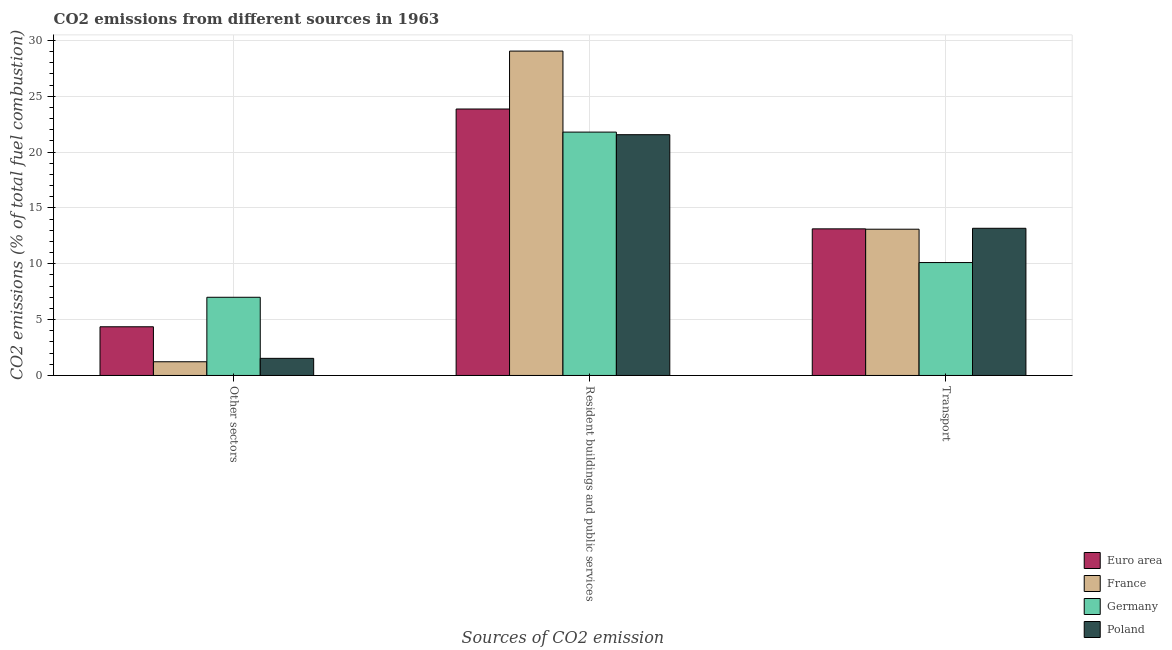How many different coloured bars are there?
Provide a short and direct response. 4. How many groups of bars are there?
Offer a terse response. 3. How many bars are there on the 1st tick from the left?
Give a very brief answer. 4. How many bars are there on the 3rd tick from the right?
Your answer should be very brief. 4. What is the label of the 3rd group of bars from the left?
Offer a very short reply. Transport. What is the percentage of co2 emissions from other sectors in Euro area?
Offer a terse response. 4.36. Across all countries, what is the maximum percentage of co2 emissions from transport?
Your response must be concise. 13.17. Across all countries, what is the minimum percentage of co2 emissions from other sectors?
Give a very brief answer. 1.23. In which country was the percentage of co2 emissions from resident buildings and public services minimum?
Provide a succinct answer. Poland. What is the total percentage of co2 emissions from other sectors in the graph?
Keep it short and to the point. 14.11. What is the difference between the percentage of co2 emissions from transport in Euro area and that in France?
Provide a succinct answer. 0.03. What is the difference between the percentage of co2 emissions from other sectors in Euro area and the percentage of co2 emissions from resident buildings and public services in France?
Keep it short and to the point. -24.68. What is the average percentage of co2 emissions from transport per country?
Provide a short and direct response. 12.37. What is the difference between the percentage of co2 emissions from resident buildings and public services and percentage of co2 emissions from transport in Euro area?
Offer a very short reply. 10.73. In how many countries, is the percentage of co2 emissions from other sectors greater than 1 %?
Your response must be concise. 4. What is the ratio of the percentage of co2 emissions from resident buildings and public services in Germany to that in Poland?
Provide a succinct answer. 1.01. Is the percentage of co2 emissions from transport in France less than that in Poland?
Your answer should be very brief. Yes. What is the difference between the highest and the second highest percentage of co2 emissions from transport?
Your answer should be very brief. 0.05. What is the difference between the highest and the lowest percentage of co2 emissions from resident buildings and public services?
Make the answer very short. 7.48. In how many countries, is the percentage of co2 emissions from other sectors greater than the average percentage of co2 emissions from other sectors taken over all countries?
Give a very brief answer. 2. What does the 3rd bar from the right in Other sectors represents?
Your answer should be very brief. France. Is it the case that in every country, the sum of the percentage of co2 emissions from other sectors and percentage of co2 emissions from resident buildings and public services is greater than the percentage of co2 emissions from transport?
Make the answer very short. Yes. How many bars are there?
Offer a very short reply. 12. Are all the bars in the graph horizontal?
Your answer should be very brief. No. How many countries are there in the graph?
Provide a succinct answer. 4. What is the title of the graph?
Your answer should be compact. CO2 emissions from different sources in 1963. What is the label or title of the X-axis?
Ensure brevity in your answer.  Sources of CO2 emission. What is the label or title of the Y-axis?
Give a very brief answer. CO2 emissions (% of total fuel combustion). What is the CO2 emissions (% of total fuel combustion) in Euro area in Other sectors?
Keep it short and to the point. 4.36. What is the CO2 emissions (% of total fuel combustion) of France in Other sectors?
Provide a succinct answer. 1.23. What is the CO2 emissions (% of total fuel combustion) of Germany in Other sectors?
Ensure brevity in your answer.  7. What is the CO2 emissions (% of total fuel combustion) in Poland in Other sectors?
Your answer should be compact. 1.53. What is the CO2 emissions (% of total fuel combustion) of Euro area in Resident buildings and public services?
Your response must be concise. 23.85. What is the CO2 emissions (% of total fuel combustion) in France in Resident buildings and public services?
Your answer should be very brief. 29.04. What is the CO2 emissions (% of total fuel combustion) in Germany in Resident buildings and public services?
Give a very brief answer. 21.78. What is the CO2 emissions (% of total fuel combustion) of Poland in Resident buildings and public services?
Keep it short and to the point. 21.55. What is the CO2 emissions (% of total fuel combustion) in Euro area in Transport?
Your response must be concise. 13.12. What is the CO2 emissions (% of total fuel combustion) in France in Transport?
Ensure brevity in your answer.  13.09. What is the CO2 emissions (% of total fuel combustion) in Germany in Transport?
Give a very brief answer. 10.11. What is the CO2 emissions (% of total fuel combustion) in Poland in Transport?
Ensure brevity in your answer.  13.17. Across all Sources of CO2 emission, what is the maximum CO2 emissions (% of total fuel combustion) of Euro area?
Provide a succinct answer. 23.85. Across all Sources of CO2 emission, what is the maximum CO2 emissions (% of total fuel combustion) in France?
Ensure brevity in your answer.  29.04. Across all Sources of CO2 emission, what is the maximum CO2 emissions (% of total fuel combustion) in Germany?
Your answer should be compact. 21.78. Across all Sources of CO2 emission, what is the maximum CO2 emissions (% of total fuel combustion) of Poland?
Your answer should be compact. 21.55. Across all Sources of CO2 emission, what is the minimum CO2 emissions (% of total fuel combustion) of Euro area?
Offer a very short reply. 4.36. Across all Sources of CO2 emission, what is the minimum CO2 emissions (% of total fuel combustion) in France?
Offer a terse response. 1.23. Across all Sources of CO2 emission, what is the minimum CO2 emissions (% of total fuel combustion) in Germany?
Offer a terse response. 7. Across all Sources of CO2 emission, what is the minimum CO2 emissions (% of total fuel combustion) in Poland?
Provide a succinct answer. 1.53. What is the total CO2 emissions (% of total fuel combustion) in Euro area in the graph?
Provide a succinct answer. 41.33. What is the total CO2 emissions (% of total fuel combustion) in France in the graph?
Provide a short and direct response. 43.35. What is the total CO2 emissions (% of total fuel combustion) of Germany in the graph?
Offer a very short reply. 38.89. What is the total CO2 emissions (% of total fuel combustion) of Poland in the graph?
Make the answer very short. 36.26. What is the difference between the CO2 emissions (% of total fuel combustion) of Euro area in Other sectors and that in Resident buildings and public services?
Make the answer very short. -19.49. What is the difference between the CO2 emissions (% of total fuel combustion) in France in Other sectors and that in Resident buildings and public services?
Offer a very short reply. -27.81. What is the difference between the CO2 emissions (% of total fuel combustion) of Germany in Other sectors and that in Resident buildings and public services?
Offer a terse response. -14.79. What is the difference between the CO2 emissions (% of total fuel combustion) in Poland in Other sectors and that in Resident buildings and public services?
Provide a succinct answer. -20.02. What is the difference between the CO2 emissions (% of total fuel combustion) in Euro area in Other sectors and that in Transport?
Provide a succinct answer. -8.77. What is the difference between the CO2 emissions (% of total fuel combustion) of France in Other sectors and that in Transport?
Make the answer very short. -11.86. What is the difference between the CO2 emissions (% of total fuel combustion) of Germany in Other sectors and that in Transport?
Give a very brief answer. -3.11. What is the difference between the CO2 emissions (% of total fuel combustion) of Poland in Other sectors and that in Transport?
Ensure brevity in your answer.  -11.64. What is the difference between the CO2 emissions (% of total fuel combustion) in Euro area in Resident buildings and public services and that in Transport?
Your response must be concise. 10.73. What is the difference between the CO2 emissions (% of total fuel combustion) of France in Resident buildings and public services and that in Transport?
Give a very brief answer. 15.94. What is the difference between the CO2 emissions (% of total fuel combustion) of Germany in Resident buildings and public services and that in Transport?
Provide a short and direct response. 11.68. What is the difference between the CO2 emissions (% of total fuel combustion) of Poland in Resident buildings and public services and that in Transport?
Keep it short and to the point. 8.38. What is the difference between the CO2 emissions (% of total fuel combustion) of Euro area in Other sectors and the CO2 emissions (% of total fuel combustion) of France in Resident buildings and public services?
Offer a very short reply. -24.68. What is the difference between the CO2 emissions (% of total fuel combustion) in Euro area in Other sectors and the CO2 emissions (% of total fuel combustion) in Germany in Resident buildings and public services?
Give a very brief answer. -17.43. What is the difference between the CO2 emissions (% of total fuel combustion) of Euro area in Other sectors and the CO2 emissions (% of total fuel combustion) of Poland in Resident buildings and public services?
Offer a terse response. -17.19. What is the difference between the CO2 emissions (% of total fuel combustion) of France in Other sectors and the CO2 emissions (% of total fuel combustion) of Germany in Resident buildings and public services?
Keep it short and to the point. -20.56. What is the difference between the CO2 emissions (% of total fuel combustion) of France in Other sectors and the CO2 emissions (% of total fuel combustion) of Poland in Resident buildings and public services?
Your answer should be compact. -20.32. What is the difference between the CO2 emissions (% of total fuel combustion) of Germany in Other sectors and the CO2 emissions (% of total fuel combustion) of Poland in Resident buildings and public services?
Provide a succinct answer. -14.55. What is the difference between the CO2 emissions (% of total fuel combustion) of Euro area in Other sectors and the CO2 emissions (% of total fuel combustion) of France in Transport?
Keep it short and to the point. -8.73. What is the difference between the CO2 emissions (% of total fuel combustion) in Euro area in Other sectors and the CO2 emissions (% of total fuel combustion) in Germany in Transport?
Make the answer very short. -5.75. What is the difference between the CO2 emissions (% of total fuel combustion) of Euro area in Other sectors and the CO2 emissions (% of total fuel combustion) of Poland in Transport?
Give a very brief answer. -8.82. What is the difference between the CO2 emissions (% of total fuel combustion) in France in Other sectors and the CO2 emissions (% of total fuel combustion) in Germany in Transport?
Your answer should be compact. -8.88. What is the difference between the CO2 emissions (% of total fuel combustion) in France in Other sectors and the CO2 emissions (% of total fuel combustion) in Poland in Transport?
Provide a short and direct response. -11.95. What is the difference between the CO2 emissions (% of total fuel combustion) in Germany in Other sectors and the CO2 emissions (% of total fuel combustion) in Poland in Transport?
Provide a short and direct response. -6.18. What is the difference between the CO2 emissions (% of total fuel combustion) in Euro area in Resident buildings and public services and the CO2 emissions (% of total fuel combustion) in France in Transport?
Offer a very short reply. 10.76. What is the difference between the CO2 emissions (% of total fuel combustion) in Euro area in Resident buildings and public services and the CO2 emissions (% of total fuel combustion) in Germany in Transport?
Your answer should be very brief. 13.74. What is the difference between the CO2 emissions (% of total fuel combustion) of Euro area in Resident buildings and public services and the CO2 emissions (% of total fuel combustion) of Poland in Transport?
Ensure brevity in your answer.  10.68. What is the difference between the CO2 emissions (% of total fuel combustion) in France in Resident buildings and public services and the CO2 emissions (% of total fuel combustion) in Germany in Transport?
Your answer should be compact. 18.93. What is the difference between the CO2 emissions (% of total fuel combustion) in France in Resident buildings and public services and the CO2 emissions (% of total fuel combustion) in Poland in Transport?
Your response must be concise. 15.86. What is the difference between the CO2 emissions (% of total fuel combustion) of Germany in Resident buildings and public services and the CO2 emissions (% of total fuel combustion) of Poland in Transport?
Provide a short and direct response. 8.61. What is the average CO2 emissions (% of total fuel combustion) in Euro area per Sources of CO2 emission?
Offer a terse response. 13.78. What is the average CO2 emissions (% of total fuel combustion) of France per Sources of CO2 emission?
Keep it short and to the point. 14.45. What is the average CO2 emissions (% of total fuel combustion) in Germany per Sources of CO2 emission?
Your answer should be very brief. 12.96. What is the average CO2 emissions (% of total fuel combustion) of Poland per Sources of CO2 emission?
Keep it short and to the point. 12.09. What is the difference between the CO2 emissions (% of total fuel combustion) of Euro area and CO2 emissions (% of total fuel combustion) of France in Other sectors?
Give a very brief answer. 3.13. What is the difference between the CO2 emissions (% of total fuel combustion) in Euro area and CO2 emissions (% of total fuel combustion) in Germany in Other sectors?
Your answer should be compact. -2.64. What is the difference between the CO2 emissions (% of total fuel combustion) of Euro area and CO2 emissions (% of total fuel combustion) of Poland in Other sectors?
Provide a succinct answer. 2.83. What is the difference between the CO2 emissions (% of total fuel combustion) of France and CO2 emissions (% of total fuel combustion) of Germany in Other sectors?
Your answer should be compact. -5.77. What is the difference between the CO2 emissions (% of total fuel combustion) in France and CO2 emissions (% of total fuel combustion) in Poland in Other sectors?
Keep it short and to the point. -0.3. What is the difference between the CO2 emissions (% of total fuel combustion) in Germany and CO2 emissions (% of total fuel combustion) in Poland in Other sectors?
Ensure brevity in your answer.  5.47. What is the difference between the CO2 emissions (% of total fuel combustion) of Euro area and CO2 emissions (% of total fuel combustion) of France in Resident buildings and public services?
Your response must be concise. -5.18. What is the difference between the CO2 emissions (% of total fuel combustion) of Euro area and CO2 emissions (% of total fuel combustion) of Germany in Resident buildings and public services?
Provide a short and direct response. 2.07. What is the difference between the CO2 emissions (% of total fuel combustion) of Euro area and CO2 emissions (% of total fuel combustion) of Poland in Resident buildings and public services?
Your response must be concise. 2.3. What is the difference between the CO2 emissions (% of total fuel combustion) in France and CO2 emissions (% of total fuel combustion) in Germany in Resident buildings and public services?
Your response must be concise. 7.25. What is the difference between the CO2 emissions (% of total fuel combustion) in France and CO2 emissions (% of total fuel combustion) in Poland in Resident buildings and public services?
Make the answer very short. 7.48. What is the difference between the CO2 emissions (% of total fuel combustion) of Germany and CO2 emissions (% of total fuel combustion) of Poland in Resident buildings and public services?
Give a very brief answer. 0.23. What is the difference between the CO2 emissions (% of total fuel combustion) in Euro area and CO2 emissions (% of total fuel combustion) in France in Transport?
Provide a short and direct response. 0.03. What is the difference between the CO2 emissions (% of total fuel combustion) in Euro area and CO2 emissions (% of total fuel combustion) in Germany in Transport?
Make the answer very short. 3.02. What is the difference between the CO2 emissions (% of total fuel combustion) in Euro area and CO2 emissions (% of total fuel combustion) in Poland in Transport?
Your answer should be compact. -0.05. What is the difference between the CO2 emissions (% of total fuel combustion) of France and CO2 emissions (% of total fuel combustion) of Germany in Transport?
Keep it short and to the point. 2.98. What is the difference between the CO2 emissions (% of total fuel combustion) in France and CO2 emissions (% of total fuel combustion) in Poland in Transport?
Offer a terse response. -0.08. What is the difference between the CO2 emissions (% of total fuel combustion) in Germany and CO2 emissions (% of total fuel combustion) in Poland in Transport?
Provide a short and direct response. -3.07. What is the ratio of the CO2 emissions (% of total fuel combustion) of Euro area in Other sectors to that in Resident buildings and public services?
Your answer should be very brief. 0.18. What is the ratio of the CO2 emissions (% of total fuel combustion) of France in Other sectors to that in Resident buildings and public services?
Your answer should be compact. 0.04. What is the ratio of the CO2 emissions (% of total fuel combustion) of Germany in Other sectors to that in Resident buildings and public services?
Your answer should be very brief. 0.32. What is the ratio of the CO2 emissions (% of total fuel combustion) in Poland in Other sectors to that in Resident buildings and public services?
Ensure brevity in your answer.  0.07. What is the ratio of the CO2 emissions (% of total fuel combustion) of Euro area in Other sectors to that in Transport?
Offer a very short reply. 0.33. What is the ratio of the CO2 emissions (% of total fuel combustion) of France in Other sectors to that in Transport?
Offer a terse response. 0.09. What is the ratio of the CO2 emissions (% of total fuel combustion) in Germany in Other sectors to that in Transport?
Provide a short and direct response. 0.69. What is the ratio of the CO2 emissions (% of total fuel combustion) in Poland in Other sectors to that in Transport?
Provide a succinct answer. 0.12. What is the ratio of the CO2 emissions (% of total fuel combustion) of Euro area in Resident buildings and public services to that in Transport?
Ensure brevity in your answer.  1.82. What is the ratio of the CO2 emissions (% of total fuel combustion) in France in Resident buildings and public services to that in Transport?
Provide a short and direct response. 2.22. What is the ratio of the CO2 emissions (% of total fuel combustion) of Germany in Resident buildings and public services to that in Transport?
Offer a very short reply. 2.16. What is the ratio of the CO2 emissions (% of total fuel combustion) of Poland in Resident buildings and public services to that in Transport?
Ensure brevity in your answer.  1.64. What is the difference between the highest and the second highest CO2 emissions (% of total fuel combustion) in Euro area?
Ensure brevity in your answer.  10.73. What is the difference between the highest and the second highest CO2 emissions (% of total fuel combustion) in France?
Ensure brevity in your answer.  15.94. What is the difference between the highest and the second highest CO2 emissions (% of total fuel combustion) of Germany?
Give a very brief answer. 11.68. What is the difference between the highest and the second highest CO2 emissions (% of total fuel combustion) of Poland?
Your answer should be compact. 8.38. What is the difference between the highest and the lowest CO2 emissions (% of total fuel combustion) of Euro area?
Offer a very short reply. 19.49. What is the difference between the highest and the lowest CO2 emissions (% of total fuel combustion) in France?
Ensure brevity in your answer.  27.81. What is the difference between the highest and the lowest CO2 emissions (% of total fuel combustion) in Germany?
Your answer should be very brief. 14.79. What is the difference between the highest and the lowest CO2 emissions (% of total fuel combustion) of Poland?
Provide a succinct answer. 20.02. 